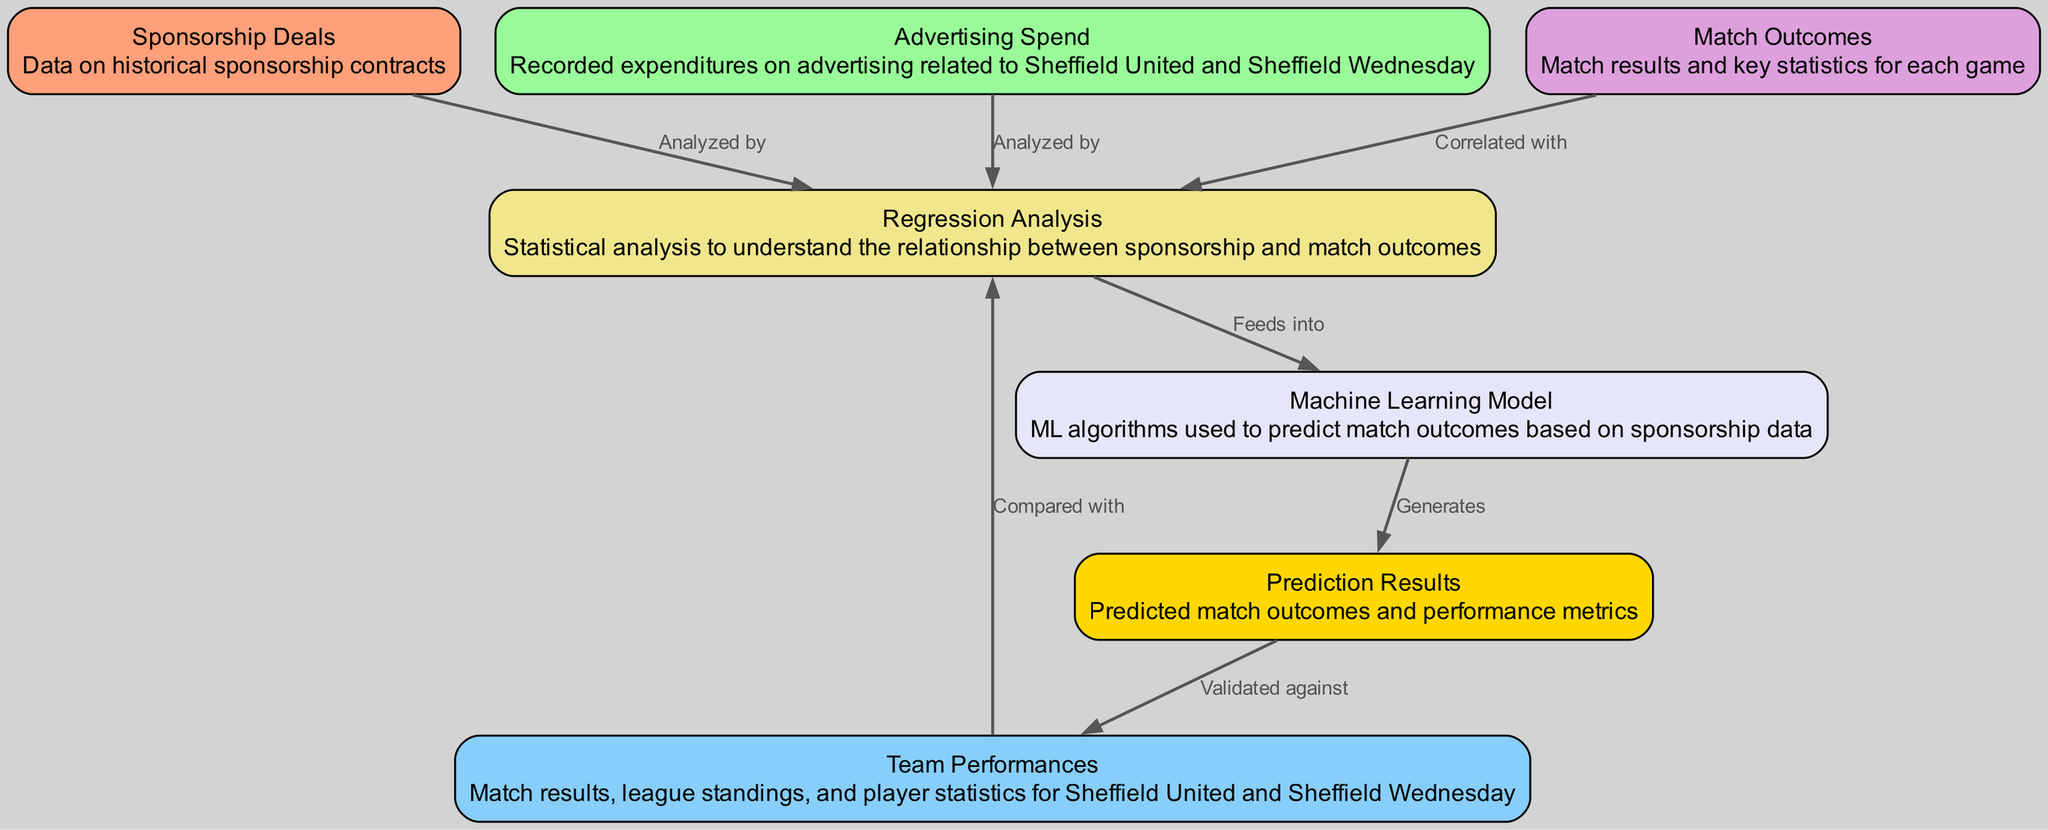What are the two main factors analyzed for their impact on match outcomes? The diagram lists "Sponsorship Deals" and "Advertising Spend" as the two main factors analyzed to understand their impact on match outcomes. These two nodes directly connect to the "Regression Analysis" node, indicating they are key variables in the analysis.
Answer: Sponsorship Deals, Advertising Spend How many nodes are present in the diagram? There are seven nodes in total in the diagram representing various elements of the Sponsorship Impact Analysis, including sponsorship deals, advertising spend, team performances, match outcomes, regression analysis, the machine learning model, and prediction results.
Answer: Seven What does "Regression Analysis" correlate with according to the diagram? "Regression Analysis" is correlated with both "Team Performances" and "Match Outcomes" as indicated by the edges connecting these nodes to "Regression Analysis." This suggests a relationship between the analyzed variables and the outcomes of the matches.
Answer: Team Performances, Match Outcomes Which node generates "Prediction Results"? The "Machine Learning Model" node generates "Prediction Results" as shown by the directed edge from the Machine Learning Model to Prediction Results. This indicates that the model produces the outcomes based on its analysis.
Answer: Prediction Results What is compared with "Team Performances" in the diagram? The node that is compared with "Team Performances" is "Regression Analysis." The diagram shows that "Team Performances" provides a comparative basis for the regression analysis, allowing the evaluation of how sponsorship and advertising affect performance.
Answer: Regression Analysis What type of analysis is used to understand the relationship between sponsorship and match outcomes? "Regression Analysis" is specifically mentioned as the type of analysis used to examine the relationship between sponsorship data and match outcomes, highlighting its role in statistical evaluation.
Answer: Regression Analysis Which nodes are analyzed by sponsorship deals? The "Sponsorship Deals" node is analyzed alongside the "Advertising Spend" node, indicating that both factors are evaluated to assess their impact on match outcomes in the analysis process.
Answer: Advertising Spend, Team Performances What does the "Prediction Results" node validate against? The "Prediction Results" node is validated against "Team Performances," implying that the outcomes predicted by the model are compared with actual performances in the matches to assess accuracy and reliability.
Answer: Team Performances 